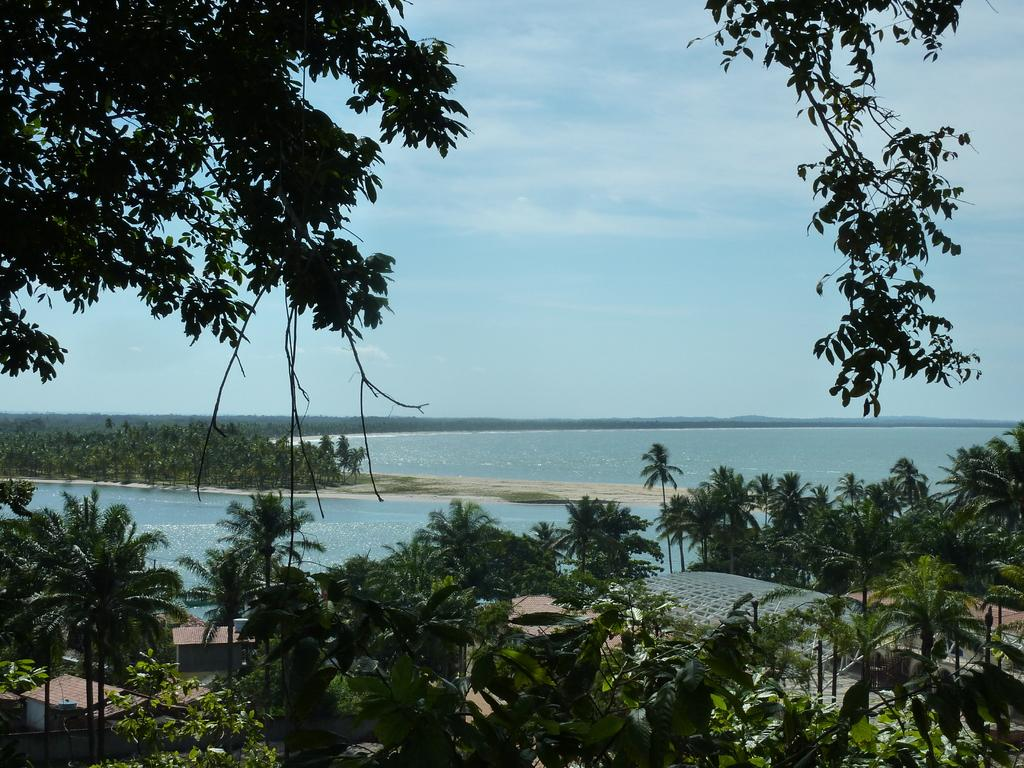What type of vegetation can be seen in the image? There are trees and plants in the image. What color are the trees and plants in the image? The trees and plants are green in color. What can be seen in the background of the image? There is water visible in the background of the image. What color is the sky in the image? The sky is blue in color. Can you see any yaks grazing on the berries in the image? There are no yaks or berries present in the image; it features trees and plants with green foliage and a blue sky. What type of town is visible in the image? There is no town present in the image; it features natural elements such as trees, plants, water, and the sky. 